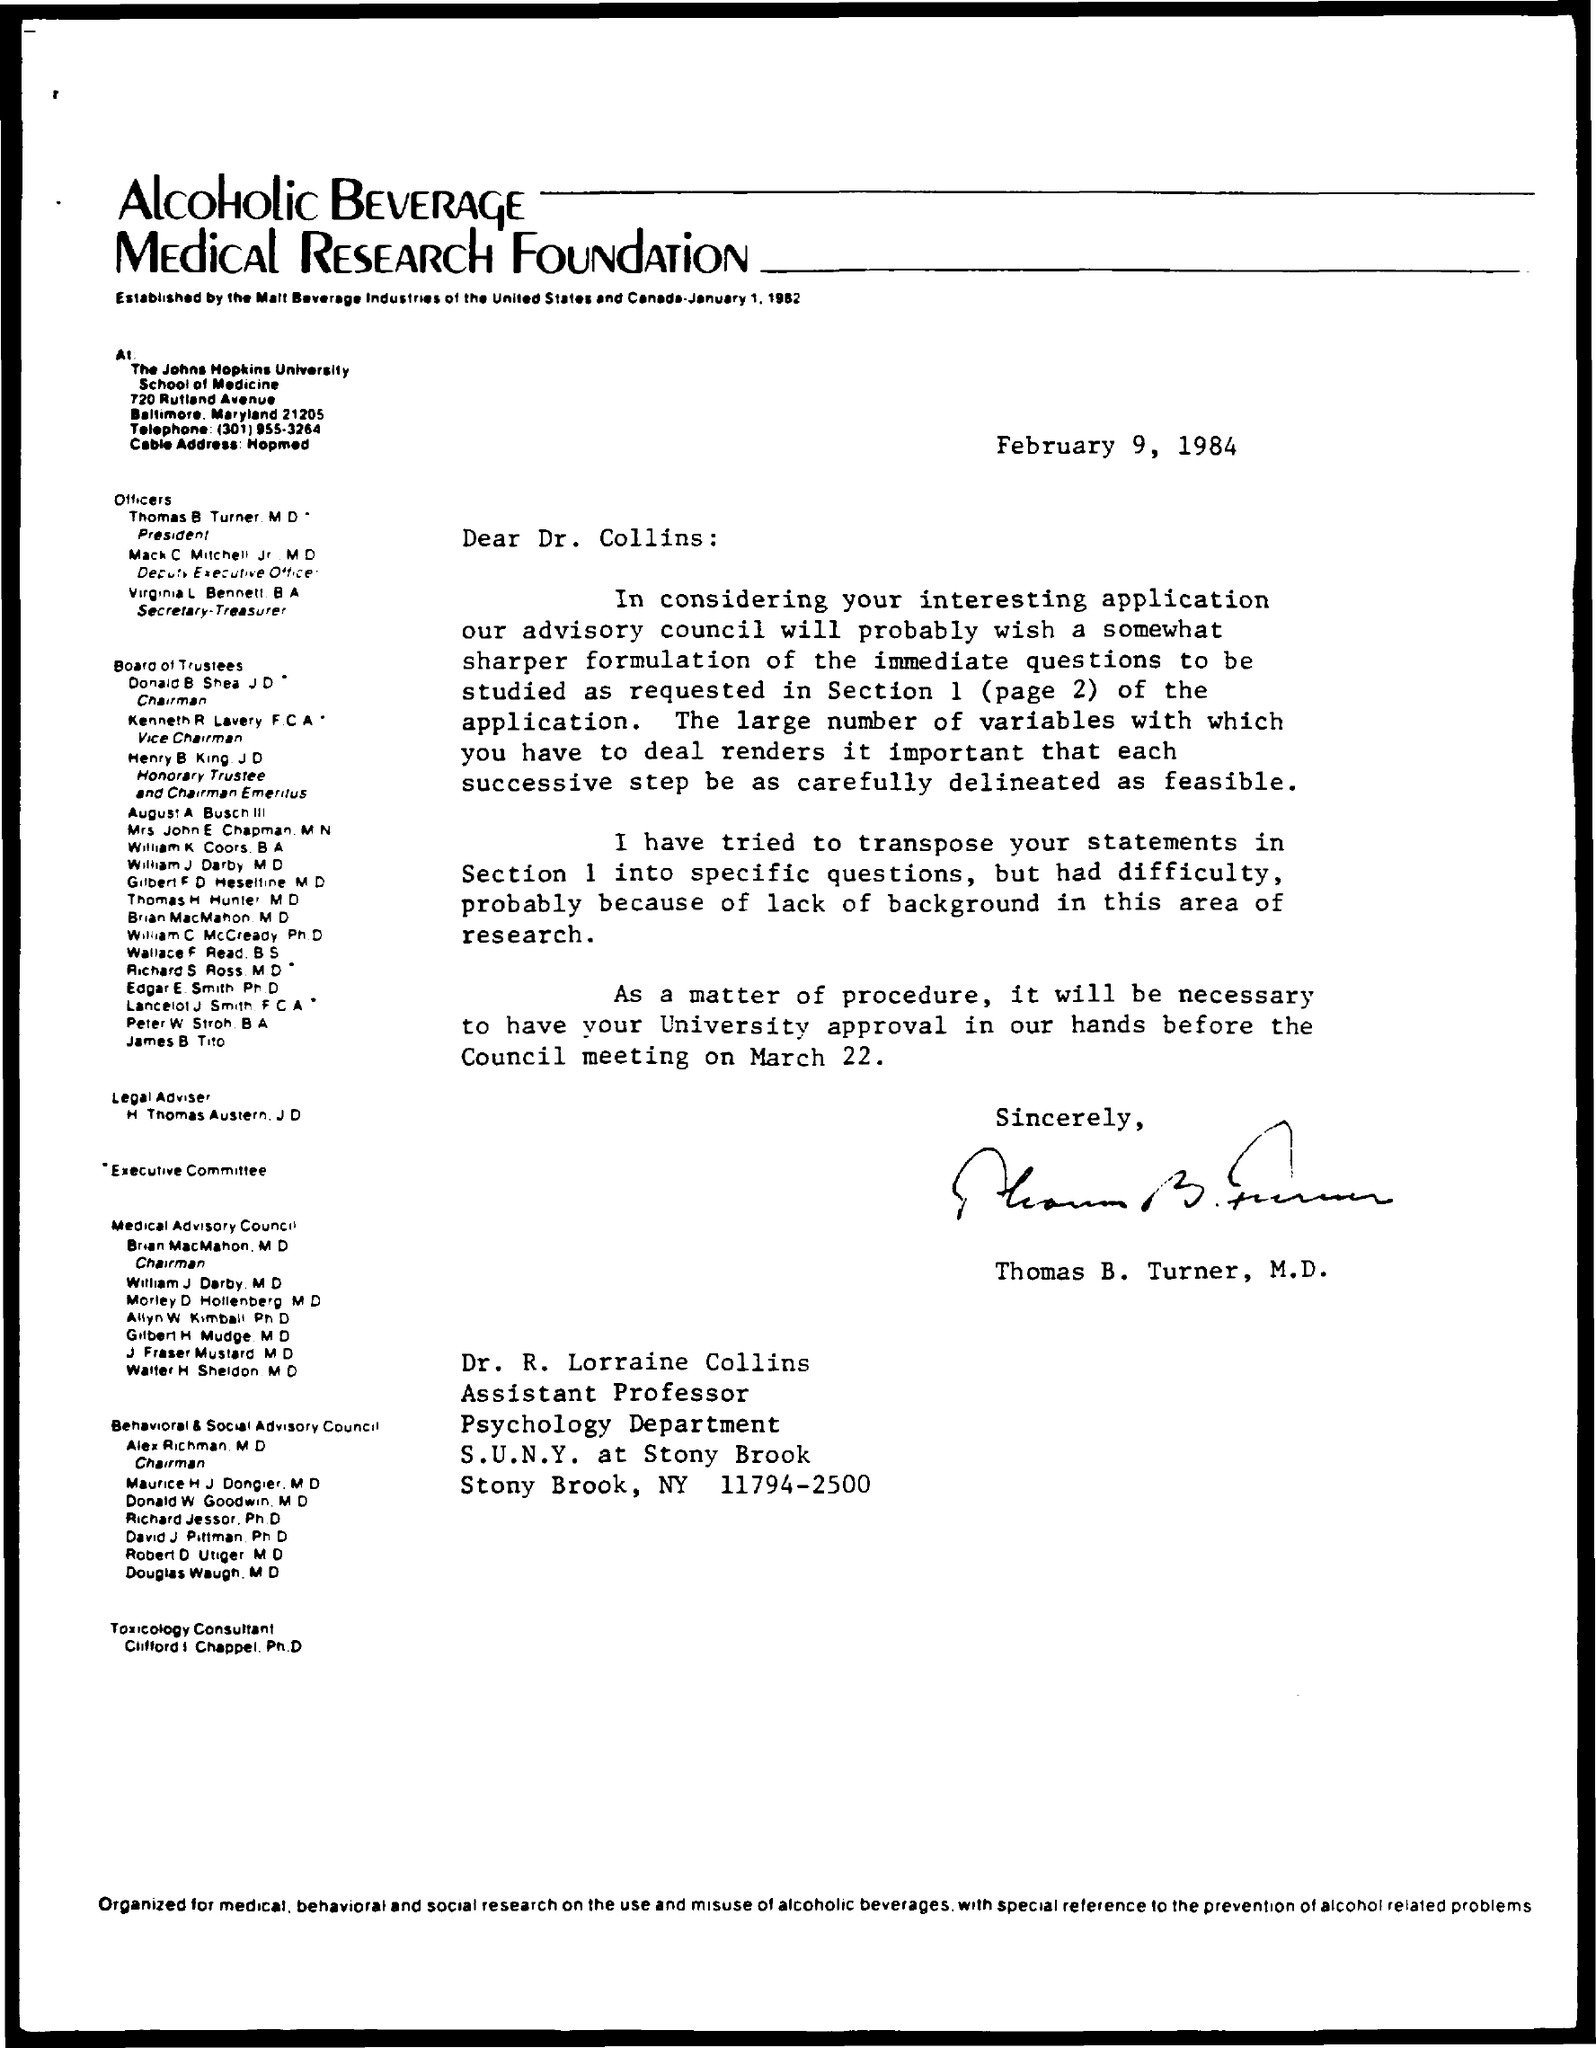To Whom is this letter addressed to?
Your answer should be compact. Dr. Collins. Who is this letter from?
Your answer should be very brief. Thomas B. Turner. 